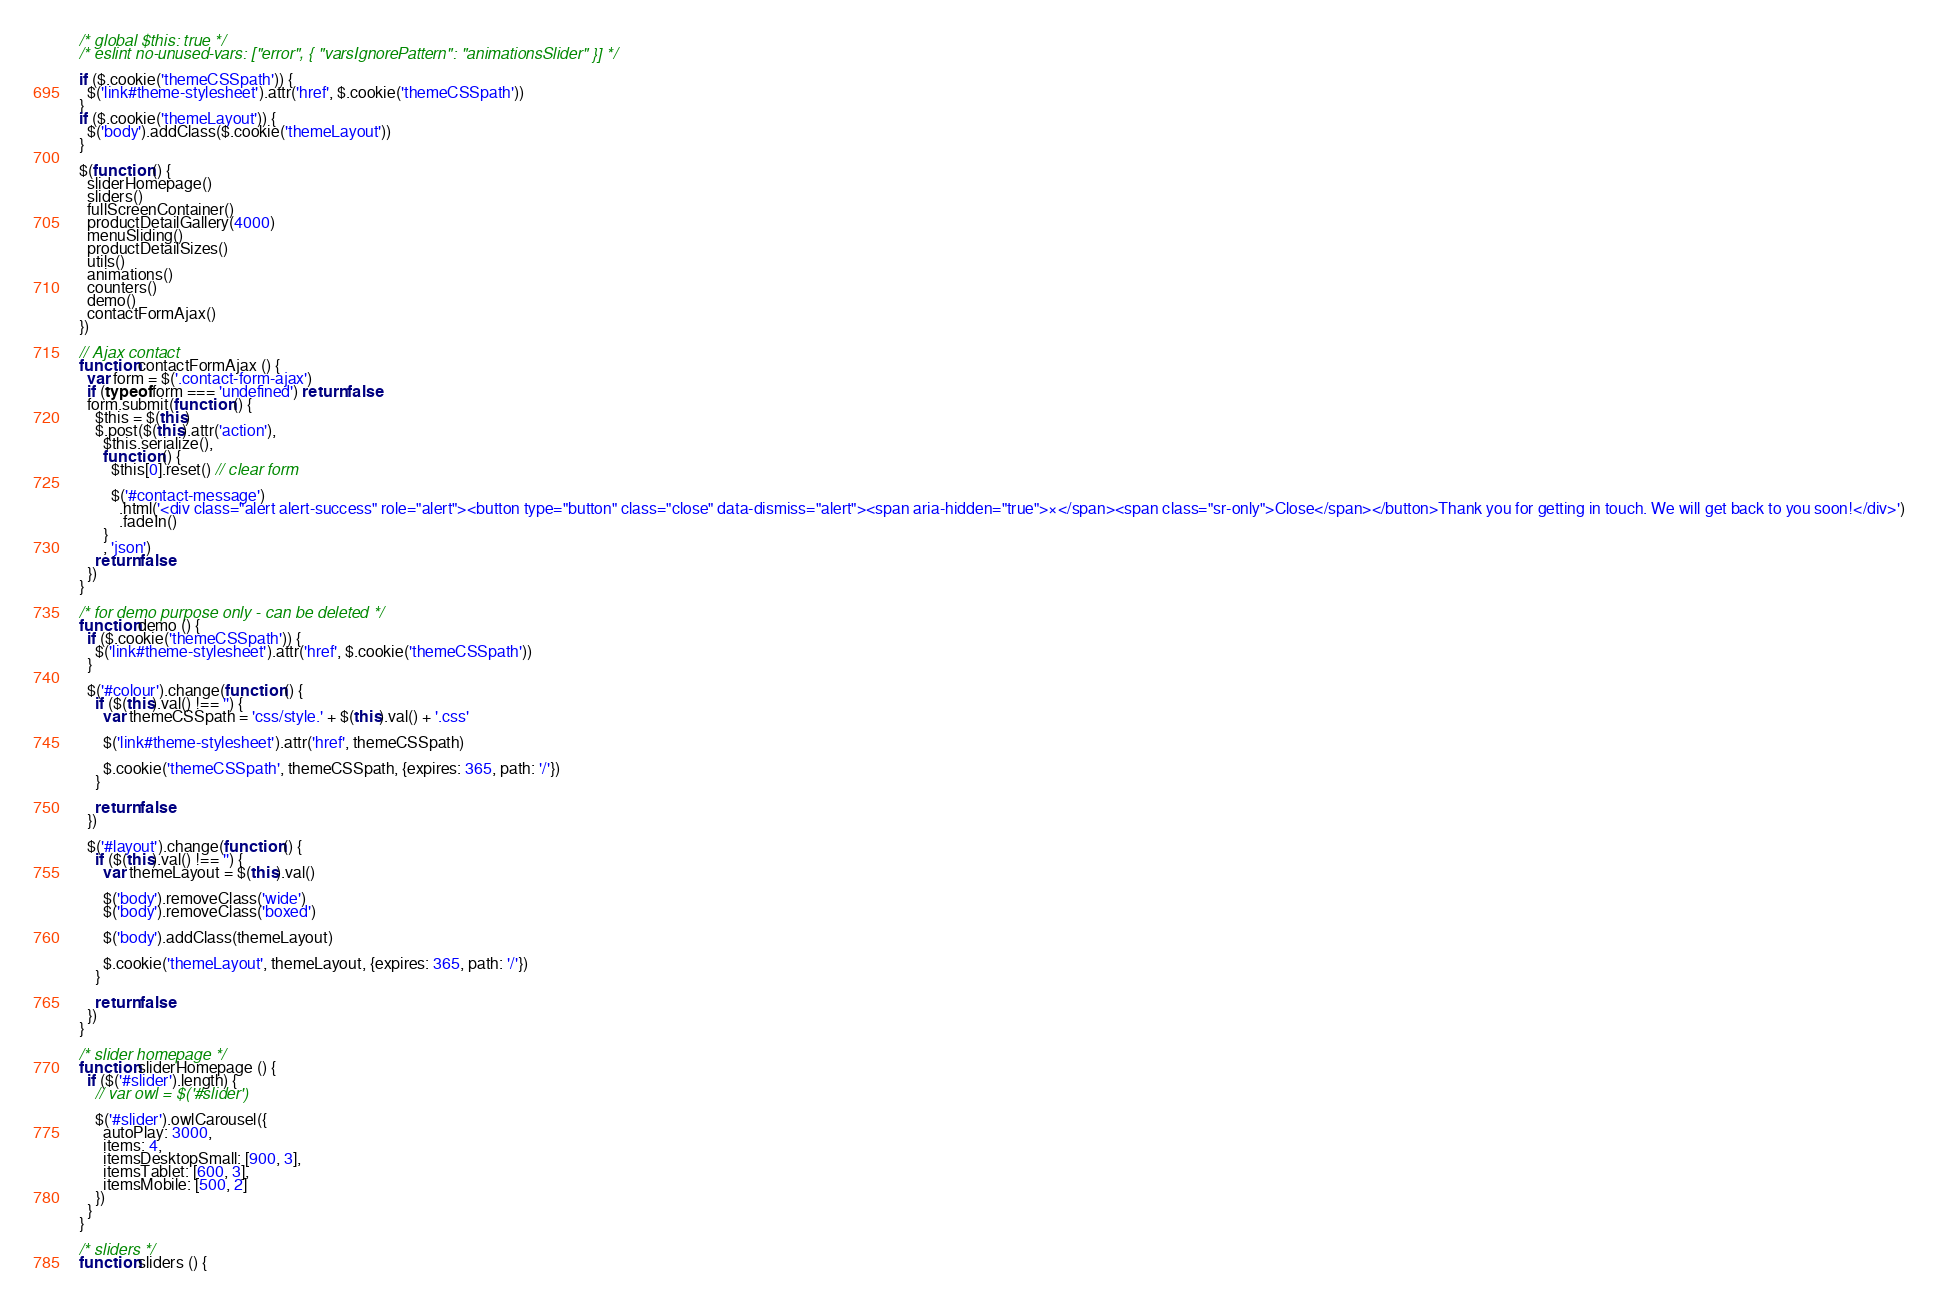Convert code to text. <code><loc_0><loc_0><loc_500><loc_500><_JavaScript_>/* global $this: true */
/* eslint no-unused-vars: ["error", { "varsIgnorePattern": "animationsSlider" }] */

if ($.cookie('themeCSSpath')) {
  $('link#theme-stylesheet').attr('href', $.cookie('themeCSSpath'))
}
if ($.cookie('themeLayout')) {
  $('body').addClass($.cookie('themeLayout'))
}

$(function () {
  sliderHomepage()
  sliders()
  fullScreenContainer()
  productDetailGallery(4000)
  menuSliding()
  productDetailSizes()
  utils()
  animations()
  counters()
  demo()
  contactFormAjax()
})

// Ajax contact
function contactFormAjax () {
  var form = $('.contact-form-ajax')
  if (typeof form === 'undefined') return false
  form.submit(function () {
    $this = $(this)
    $.post($(this).attr('action'),
      $this.serialize(),
      function () {
        $this[0].reset() // clear form

        $('#contact-message')
          .html('<div class="alert alert-success" role="alert"><button type="button" class="close" data-dismiss="alert"><span aria-hidden="true">×</span><span class="sr-only">Close</span></button>Thank you for getting in touch. We will get back to you soon!</div>')
          .fadeIn()
      }
      , 'json')
    return false
  })
}

/* for demo purpose only - can be deleted */
function demo () {
  if ($.cookie('themeCSSpath')) {
    $('link#theme-stylesheet').attr('href', $.cookie('themeCSSpath'))
  }

  $('#colour').change(function () {
    if ($(this).val() !== '') {
      var themeCSSpath = 'css/style.' + $(this).val() + '.css'

      $('link#theme-stylesheet').attr('href', themeCSSpath)

      $.cookie('themeCSSpath', themeCSSpath, {expires: 365, path: '/'})
    }

    return false
  })

  $('#layout').change(function () {
    if ($(this).val() !== '') {
      var themeLayout = $(this).val()

      $('body').removeClass('wide')
      $('body').removeClass('boxed')

      $('body').addClass(themeLayout)

      $.cookie('themeLayout', themeLayout, {expires: 365, path: '/'})
    }

    return false
  })
}

/* slider homepage */
function sliderHomepage () {
  if ($('#slider').length) {
    // var owl = $('#slider')

    $('#slider').owlCarousel({
      autoPlay: 3000,
      items: 4,
      itemsDesktopSmall: [900, 3],
      itemsTablet: [600, 3],
      itemsMobile: [500, 2]
    })
  }
}

/* sliders */
function sliders () {</code> 